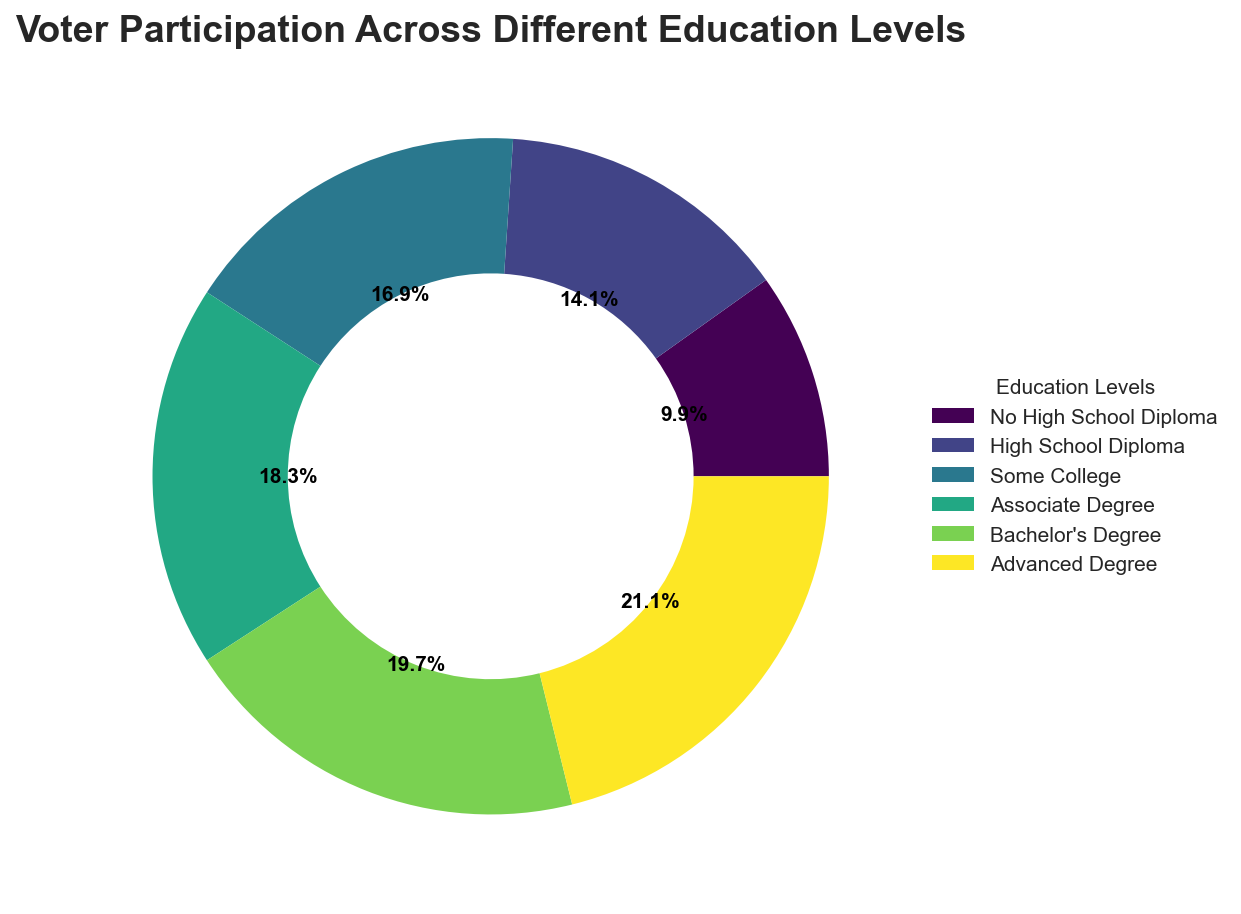Which education level has the highest voter participation? The ring chart shows that the "Advanced Degree" category has the highest percentage, depicted as the largest wedge.
Answer: Advanced Degree Which education level has a voter participation rate of 65%? By matching the percentage provided (65%) with the labels in the chart, the "Associate Degree" category fits.
Answer: Associate Degree Is the voter participation of individuals with a bachelor's degree higher or lower than those with some college education? The percentage for a Bachelor's Degree (70%) is compared to Some College (60%), showing the former is higher.
Answer: Higher What is the difference in voter participation between individuals with no high school diploma and those with a high school diploma? The chart shows No High School Diploma at 35% and High School Diploma at 50%. Subtracting 35% from 50% gives the difference (50% - 35%).
Answer: 15% What is the average voter participation rate across all education levels? The percentages for each level are summed: 35 + 50 + 60 + 65 + 70 + 75 = 355. The number of categories is 6. The average is 355 / 6.
Answer: 59.2 What is the total percentage of voter participation for those with an Associate Degree or higher? Combining the respective percentages: 65% (Associate Degree) + 70% (Bachelor's Degree) + 75% (Advanced Degree) results in 65 + 70 + 75 = 210.
Answer: 210% How does the participation rate for "Some College" compare visually to that of the "Advanced Degree"? Visually, the wedge for "Some College" (60%) is smaller than the one for "Advanced Degree" (75%), indicating a lower participation rate.
Answer: Smaller What percentage of the total participation is represented by people with at least a Bachelor's degree? Bachelor's Degree (70%) plus Advanced Degree (75%) gives 70 + 75, resulting in 145%.
Answer: 145% Identify the education level closest in voter participation to 50%. The percentages surrounding 50% are evaluated, and the "High School Diploma" closest matches at precisely 50%.
Answer: High School Diploma 